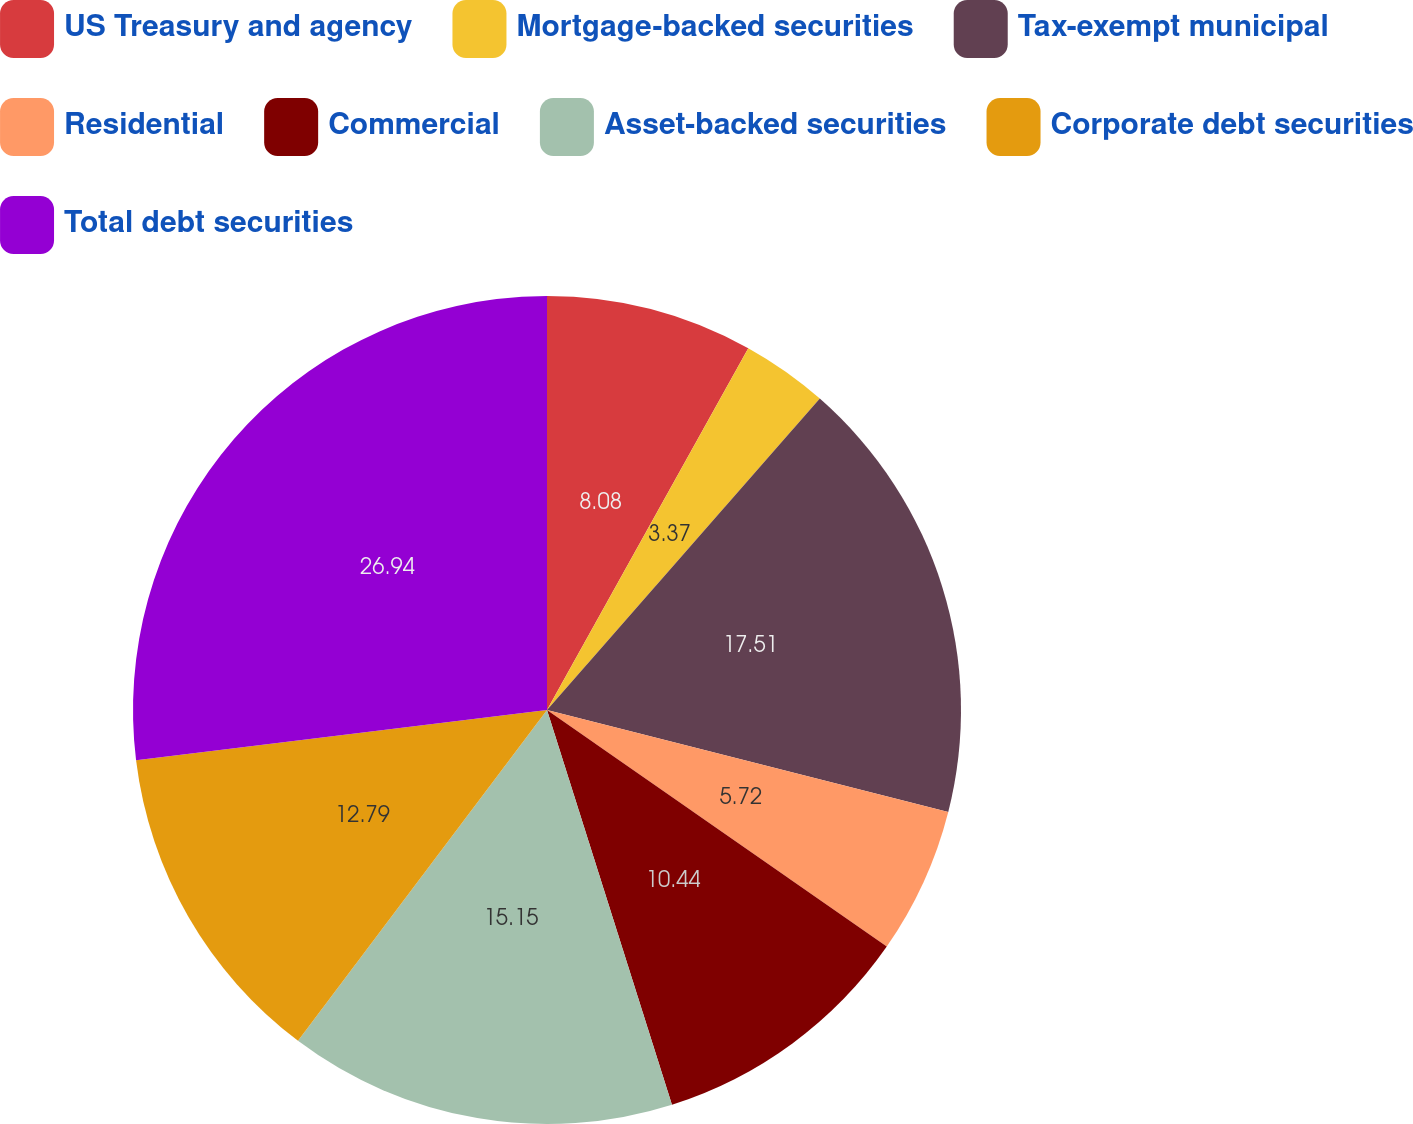<chart> <loc_0><loc_0><loc_500><loc_500><pie_chart><fcel>US Treasury and agency<fcel>Mortgage-backed securities<fcel>Tax-exempt municipal<fcel>Residential<fcel>Commercial<fcel>Asset-backed securities<fcel>Corporate debt securities<fcel>Total debt securities<nl><fcel>8.08%<fcel>3.37%<fcel>17.51%<fcel>5.72%<fcel>10.44%<fcel>15.15%<fcel>12.79%<fcel>26.94%<nl></chart> 